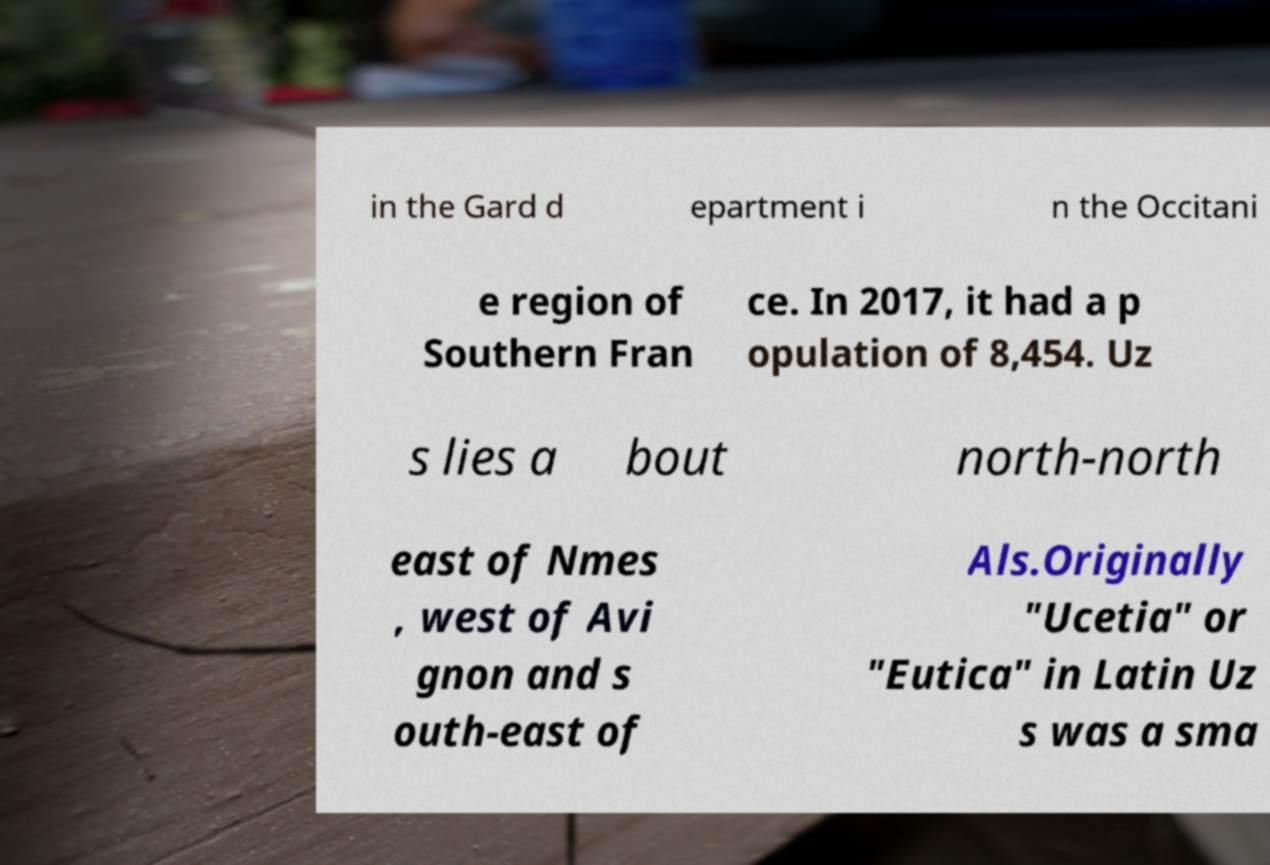Please read and relay the text visible in this image. What does it say? in the Gard d epartment i n the Occitani e region of Southern Fran ce. In 2017, it had a p opulation of 8,454. Uz s lies a bout north-north east of Nmes , west of Avi gnon and s outh-east of Als.Originally "Ucetia" or "Eutica" in Latin Uz s was a sma 